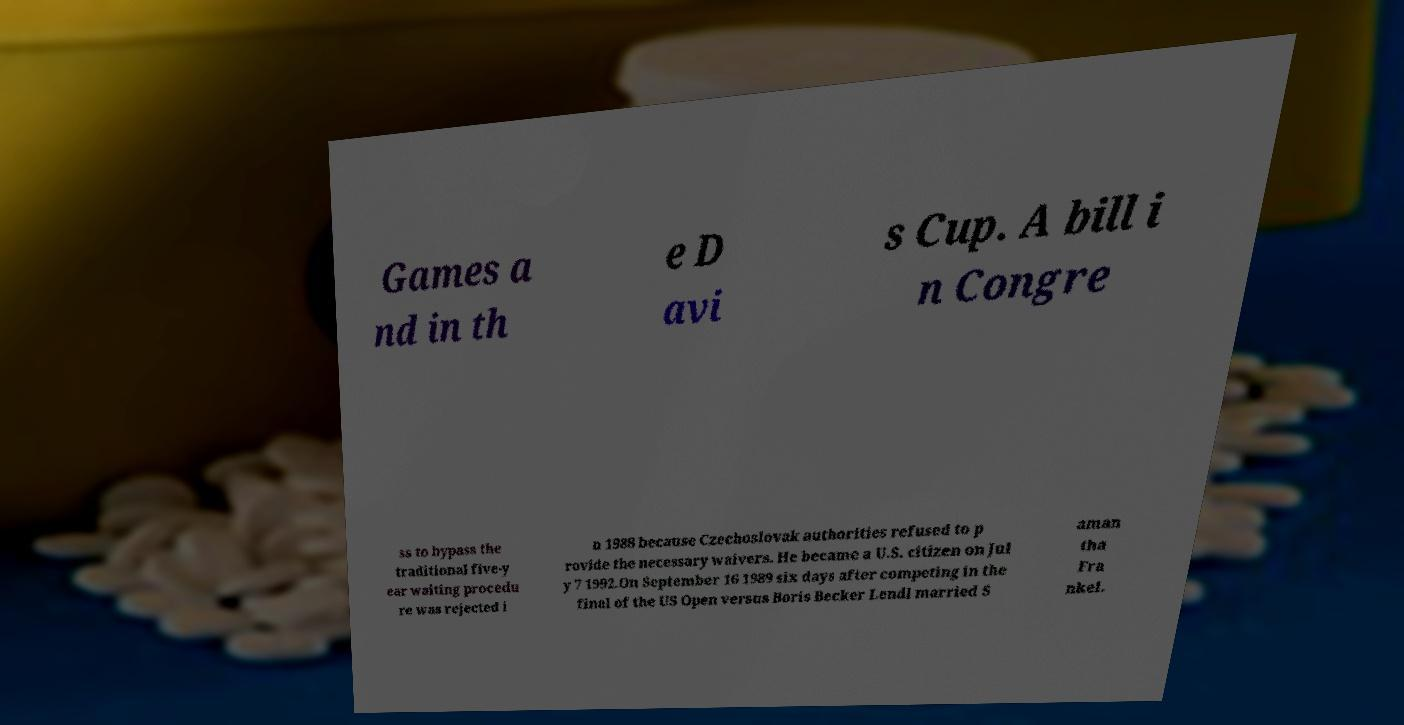Please identify and transcribe the text found in this image. Games a nd in th e D avi s Cup. A bill i n Congre ss to bypass the traditional five-y ear waiting procedu re was rejected i n 1988 because Czechoslovak authorities refused to p rovide the necessary waivers. He became a U.S. citizen on Jul y 7 1992.On September 16 1989 six days after competing in the final of the US Open versus Boris Becker Lendl married S aman tha Fra nkel. 